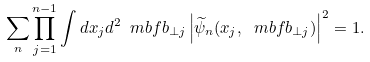Convert formula to latex. <formula><loc_0><loc_0><loc_500><loc_500>\sum _ { n } \prod _ { j = 1 } ^ { n - 1 } \int d x _ { j } d ^ { 2 } \ m b f { b } _ { \perp j } \left | \widetilde { \psi } _ { n } ( x _ { j } , \ m b f { b } _ { \perp j } ) \right | ^ { 2 } = 1 .</formula> 